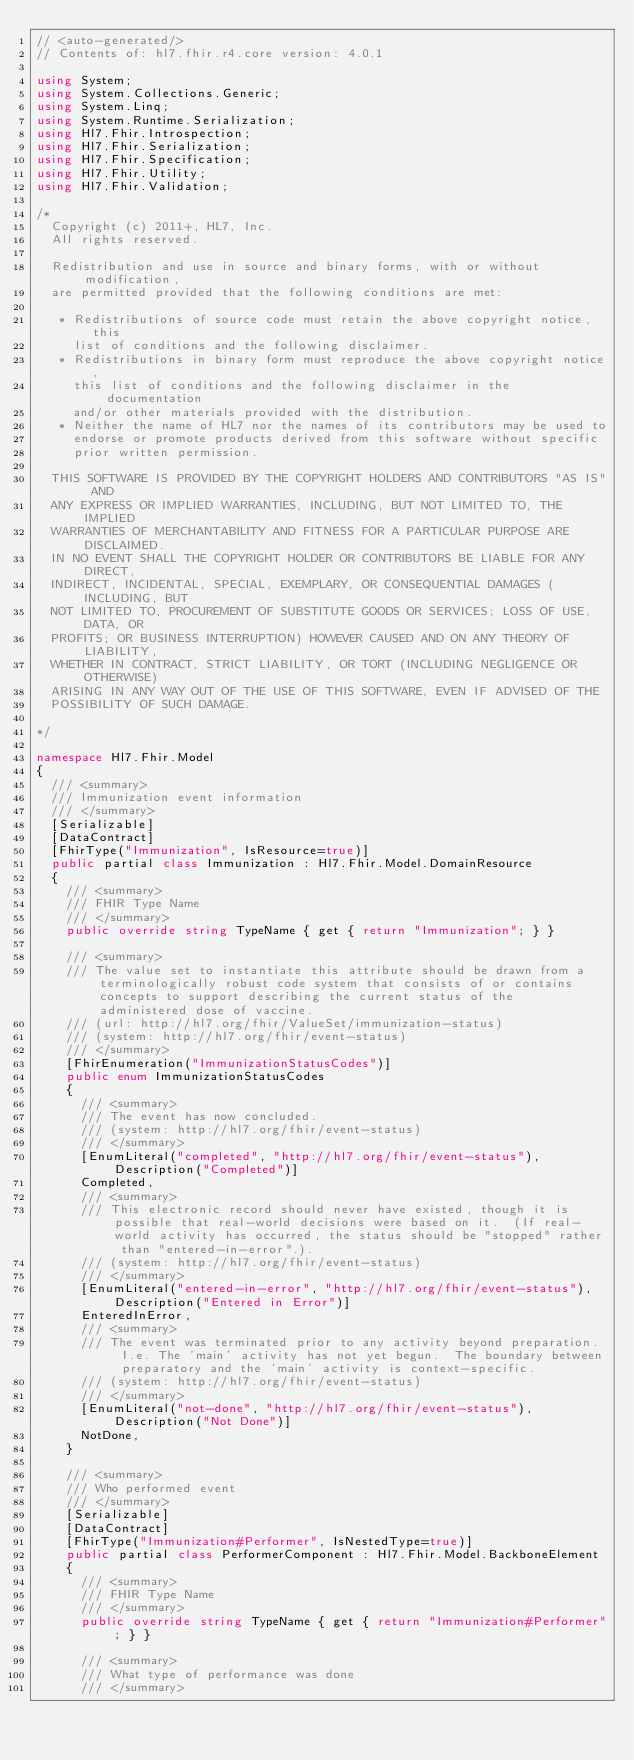Convert code to text. <code><loc_0><loc_0><loc_500><loc_500><_C#_>// <auto-generated/>
// Contents of: hl7.fhir.r4.core version: 4.0.1

using System;
using System.Collections.Generic;
using System.Linq;
using System.Runtime.Serialization;
using Hl7.Fhir.Introspection;
using Hl7.Fhir.Serialization;
using Hl7.Fhir.Specification;
using Hl7.Fhir.Utility;
using Hl7.Fhir.Validation;

/*
  Copyright (c) 2011+, HL7, Inc.
  All rights reserved.
  
  Redistribution and use in source and binary forms, with or without modification, 
  are permitted provided that the following conditions are met:
  
   * Redistributions of source code must retain the above copyright notice, this 
     list of conditions and the following disclaimer.
   * Redistributions in binary form must reproduce the above copyright notice, 
     this list of conditions and the following disclaimer in the documentation 
     and/or other materials provided with the distribution.
   * Neither the name of HL7 nor the names of its contributors may be used to 
     endorse or promote products derived from this software without specific 
     prior written permission.
  
  THIS SOFTWARE IS PROVIDED BY THE COPYRIGHT HOLDERS AND CONTRIBUTORS "AS IS" AND 
  ANY EXPRESS OR IMPLIED WARRANTIES, INCLUDING, BUT NOT LIMITED TO, THE IMPLIED 
  WARRANTIES OF MERCHANTABILITY AND FITNESS FOR A PARTICULAR PURPOSE ARE DISCLAIMED. 
  IN NO EVENT SHALL THE COPYRIGHT HOLDER OR CONTRIBUTORS BE LIABLE FOR ANY DIRECT, 
  INDIRECT, INCIDENTAL, SPECIAL, EXEMPLARY, OR CONSEQUENTIAL DAMAGES (INCLUDING, BUT 
  NOT LIMITED TO, PROCUREMENT OF SUBSTITUTE GOODS OR SERVICES; LOSS OF USE, DATA, OR 
  PROFITS; OR BUSINESS INTERRUPTION) HOWEVER CAUSED AND ON ANY THEORY OF LIABILITY, 
  WHETHER IN CONTRACT, STRICT LIABILITY, OR TORT (INCLUDING NEGLIGENCE OR OTHERWISE) 
  ARISING IN ANY WAY OUT OF THE USE OF THIS SOFTWARE, EVEN IF ADVISED OF THE 
  POSSIBILITY OF SUCH DAMAGE.
  
*/

namespace Hl7.Fhir.Model
{
  /// <summary>
  /// Immunization event information
  /// </summary>
  [Serializable]
  [DataContract]
  [FhirType("Immunization", IsResource=true)]
  public partial class Immunization : Hl7.Fhir.Model.DomainResource
  {
    /// <summary>
    /// FHIR Type Name
    /// </summary>
    public override string TypeName { get { return "Immunization"; } }

    /// <summary>
    /// The value set to instantiate this attribute should be drawn from a terminologically robust code system that consists of or contains concepts to support describing the current status of the administered dose of vaccine.
    /// (url: http://hl7.org/fhir/ValueSet/immunization-status)
    /// (system: http://hl7.org/fhir/event-status)
    /// </summary>
    [FhirEnumeration("ImmunizationStatusCodes")]
    public enum ImmunizationStatusCodes
    {
      /// <summary>
      /// The event has now concluded.
      /// (system: http://hl7.org/fhir/event-status)
      /// </summary>
      [EnumLiteral("completed", "http://hl7.org/fhir/event-status"), Description("Completed")]
      Completed,
      /// <summary>
      /// This electronic record should never have existed, though it is possible that real-world decisions were based on it.  (If real-world activity has occurred, the status should be "stopped" rather than "entered-in-error".).
      /// (system: http://hl7.org/fhir/event-status)
      /// </summary>
      [EnumLiteral("entered-in-error", "http://hl7.org/fhir/event-status"), Description("Entered in Error")]
      EnteredInError,
      /// <summary>
      /// The event was terminated prior to any activity beyond preparation.  I.e. The 'main' activity has not yet begun.  The boundary between preparatory and the 'main' activity is context-specific.
      /// (system: http://hl7.org/fhir/event-status)
      /// </summary>
      [EnumLiteral("not-done", "http://hl7.org/fhir/event-status"), Description("Not Done")]
      NotDone,
    }

    /// <summary>
    /// Who performed event
    /// </summary>
    [Serializable]
    [DataContract]
    [FhirType("Immunization#Performer", IsNestedType=true)]
    public partial class PerformerComponent : Hl7.Fhir.Model.BackboneElement
    {
      /// <summary>
      /// FHIR Type Name
      /// </summary>
      public override string TypeName { get { return "Immunization#Performer"; } }

      /// <summary>
      /// What type of performance was done
      /// </summary></code> 